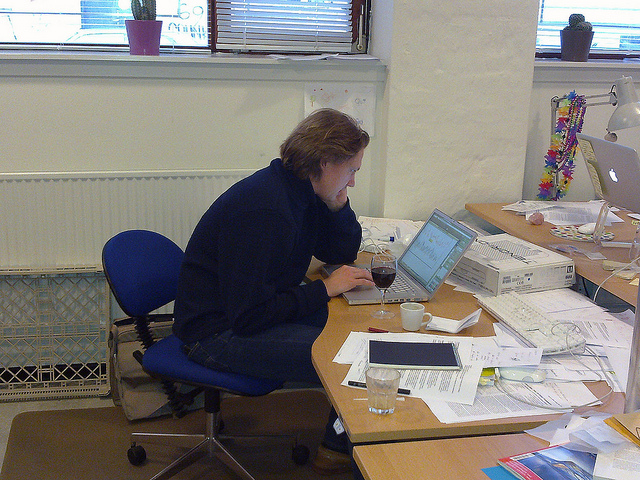Which liquid is most likely to be spilled on a laptop here? The most likely liquid to be spilled on the laptop in the image appears to be red wine, given the visible glass positioned near the computer. The precarious placement of the glass at the edge of the table, coupled with the focused attention of the person on the laptop, increases the risk of accidental spillage. 